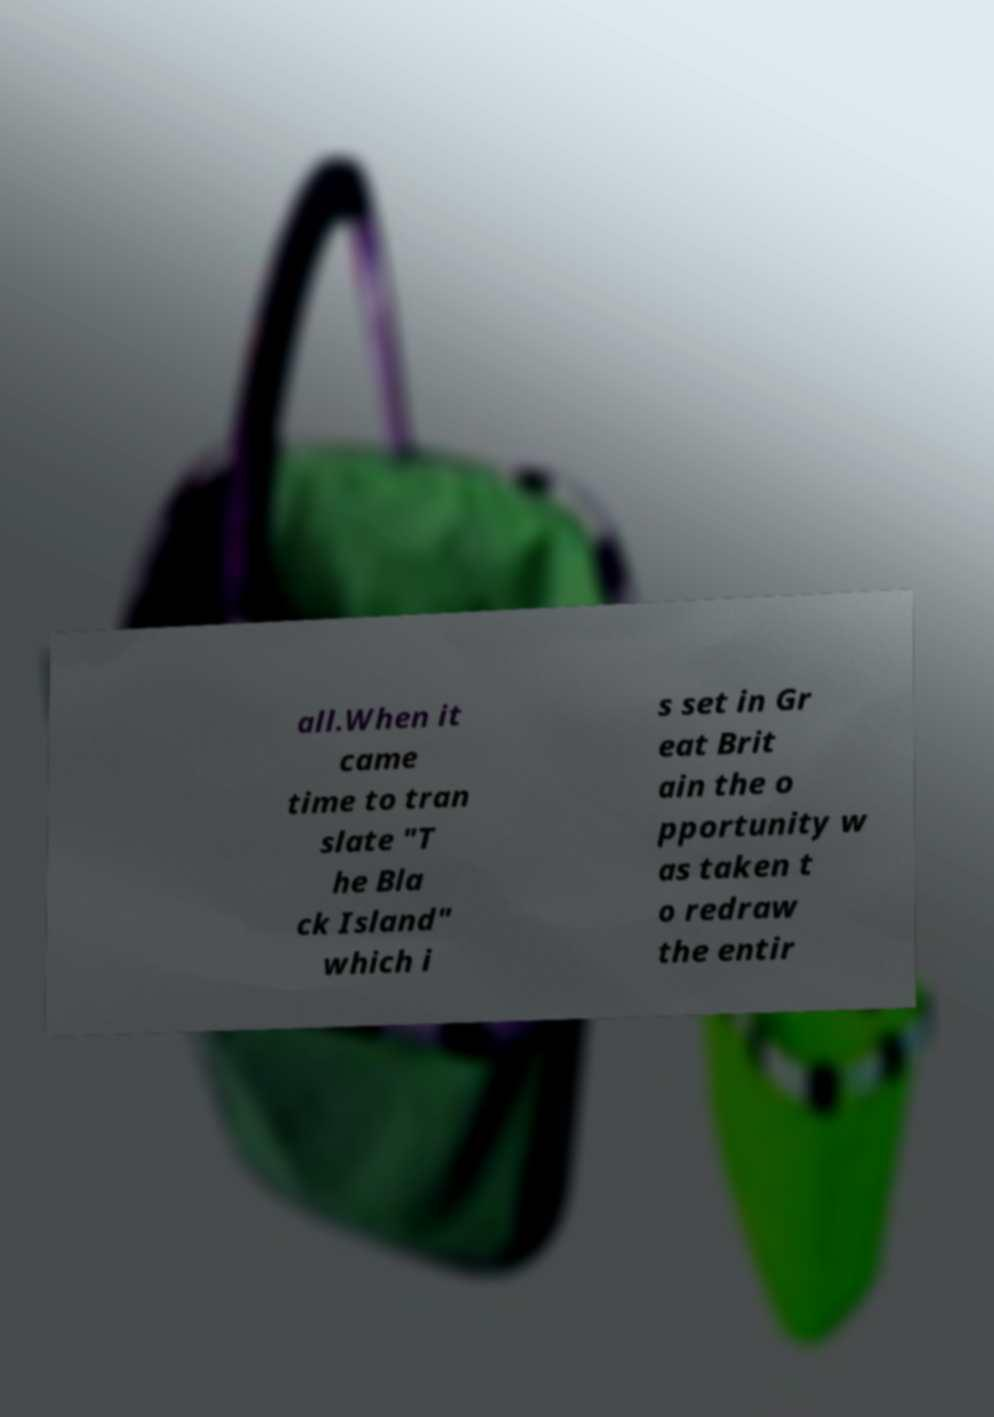Could you assist in decoding the text presented in this image and type it out clearly? all.When it came time to tran slate "T he Bla ck Island" which i s set in Gr eat Brit ain the o pportunity w as taken t o redraw the entir 